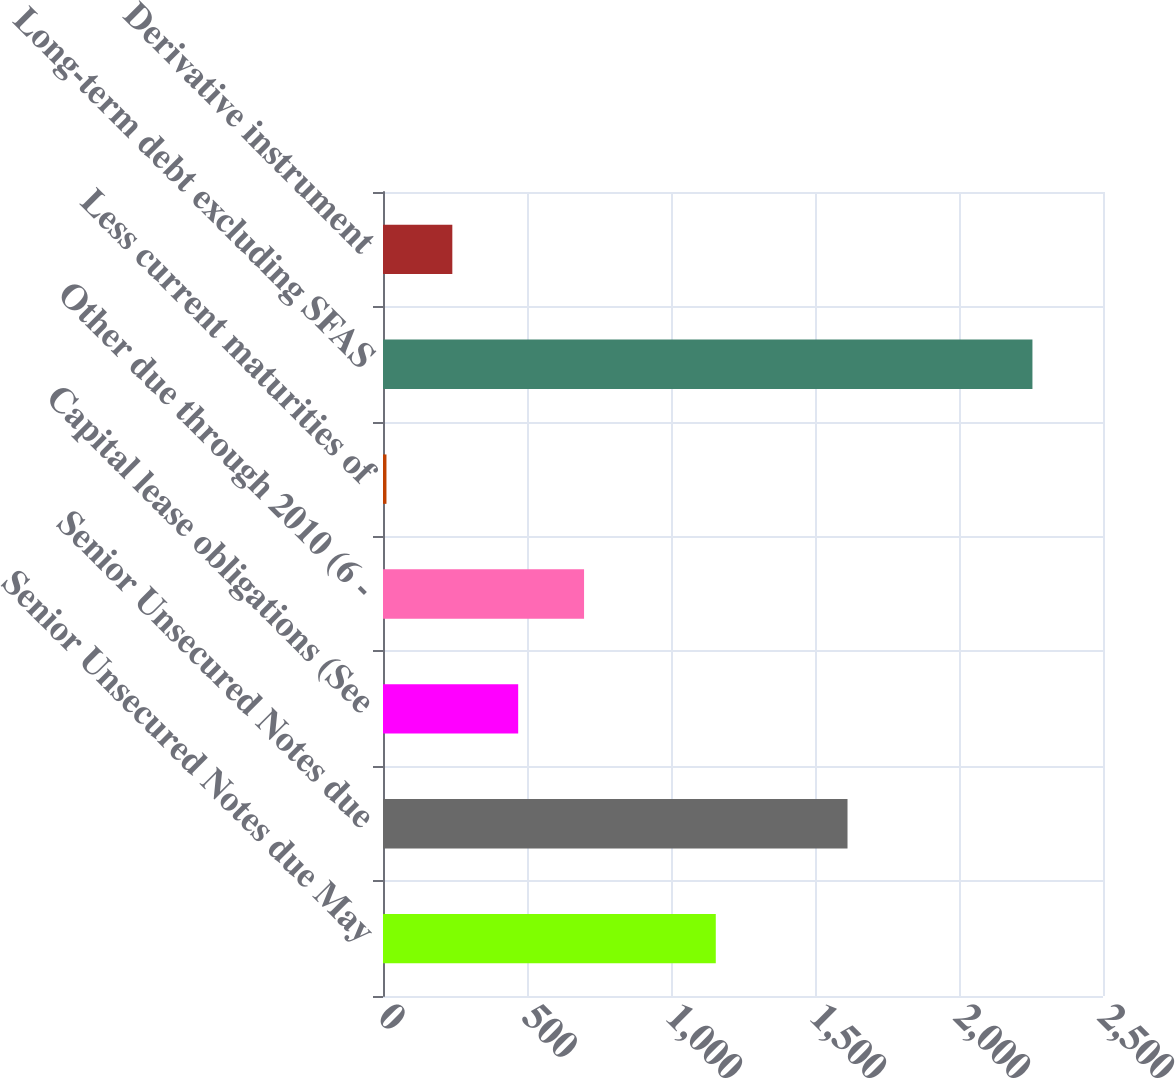<chart> <loc_0><loc_0><loc_500><loc_500><bar_chart><fcel>Senior Unsecured Notes due May<fcel>Senior Unsecured Notes due<fcel>Capital lease obligations (See<fcel>Other due through 2010 (6 -<fcel>Less current maturities of<fcel>Long-term debt excluding SFAS<fcel>Derivative instrument<nl><fcel>1155.5<fcel>1612.9<fcel>469.4<fcel>698.1<fcel>12<fcel>2255<fcel>240.7<nl></chart> 